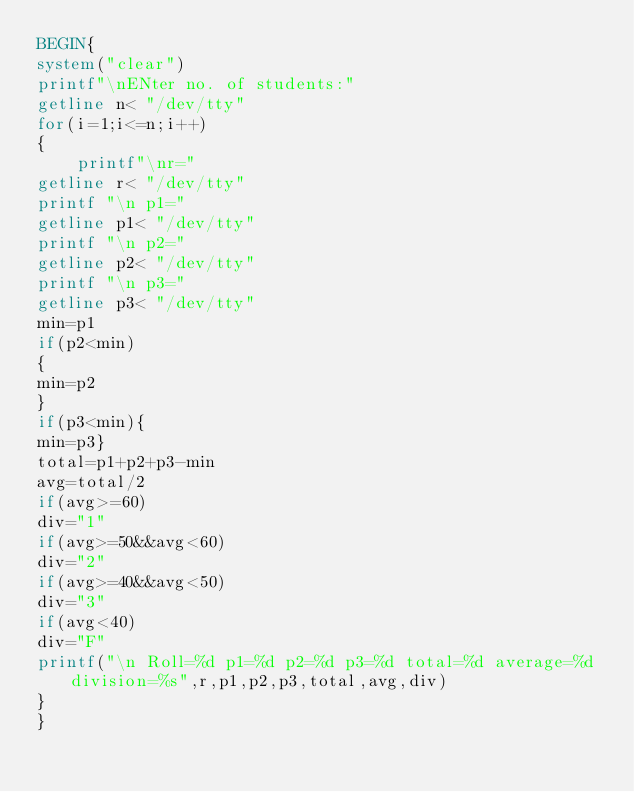Convert code to text. <code><loc_0><loc_0><loc_500><loc_500><_Awk_>BEGIN{
system("clear")
printf"\nENter no. of students:"
getline n< "/dev/tty"
for(i=1;i<=n;i++)
{
	printf"\nr="
getline r< "/dev/tty"
printf "\n p1="
getline p1< "/dev/tty"
printf "\n p2="
getline p2< "/dev/tty"
printf "\n p3="
getline p3< "/dev/tty"
min=p1
if(p2<min)
{
min=p2
}
if(p3<min){
min=p3}
total=p1+p2+p3-min
avg=total/2
if(avg>=60)
div="1"
if(avg>=50&&avg<60)
div="2"
if(avg>=40&&avg<50)
div="3"
if(avg<40)
div="F"
printf("\n Roll=%d p1=%d p2=%d p3=%d total=%d average=%d division=%s",r,p1,p2,p3,total,avg,div)
}
}
</code> 